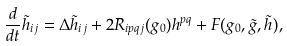Convert formula to latex. <formula><loc_0><loc_0><loc_500><loc_500>\frac { d } { d t } \tilde { h } _ { i j } = \Delta \tilde { h } _ { i j } + 2 R _ { i p q j } ( g _ { 0 } ) h ^ { p q } + F ( g _ { 0 } , \tilde { g } , \tilde { h } ) ,</formula> 